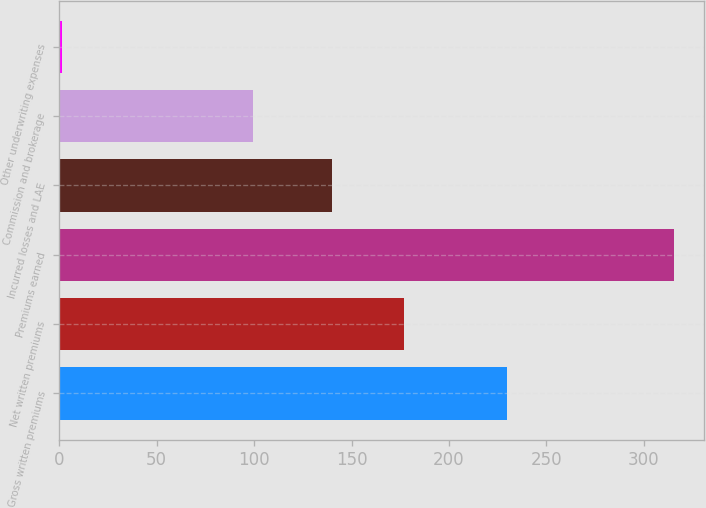Convert chart. <chart><loc_0><loc_0><loc_500><loc_500><bar_chart><fcel>Gross written premiums<fcel>Net written premiums<fcel>Premiums earned<fcel>Incurred losses and LAE<fcel>Commission and brokerage<fcel>Other underwriting expenses<nl><fcel>229.9<fcel>176.7<fcel>315.3<fcel>139.9<fcel>99.4<fcel>1.6<nl></chart> 